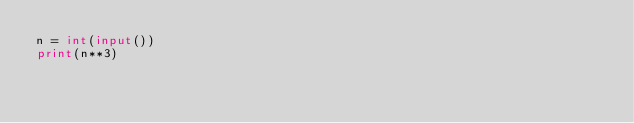Convert code to text. <code><loc_0><loc_0><loc_500><loc_500><_Python_>n = int(input())
print(n**3)</code> 